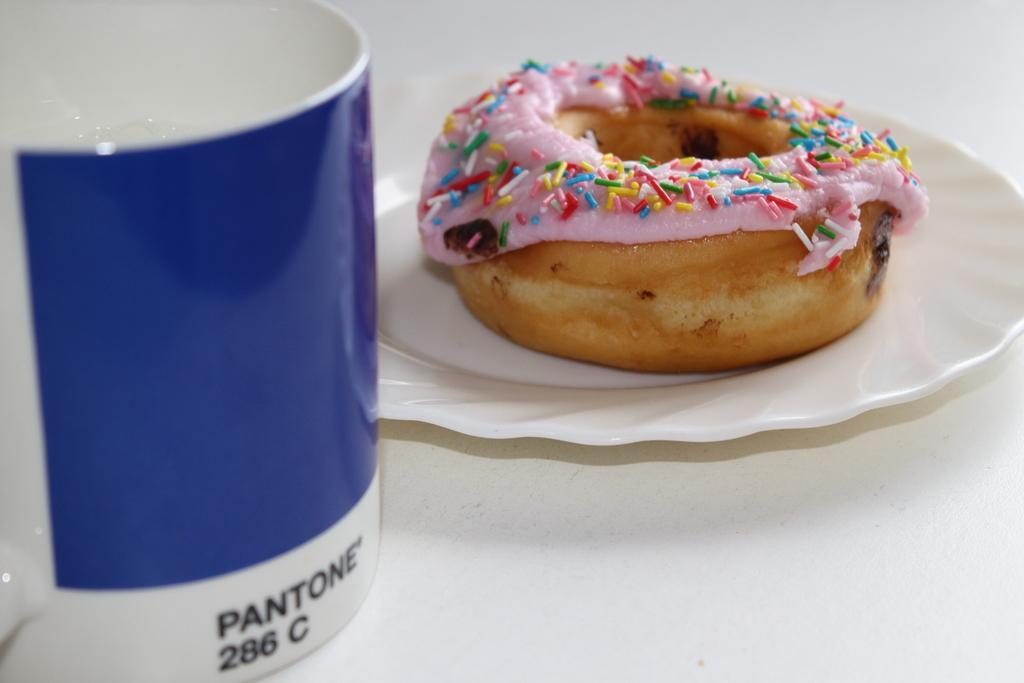Describe this image in one or two sentences. This image consist of food which is on the plate and on the left side there is a cup with some text and numbers written on it. 